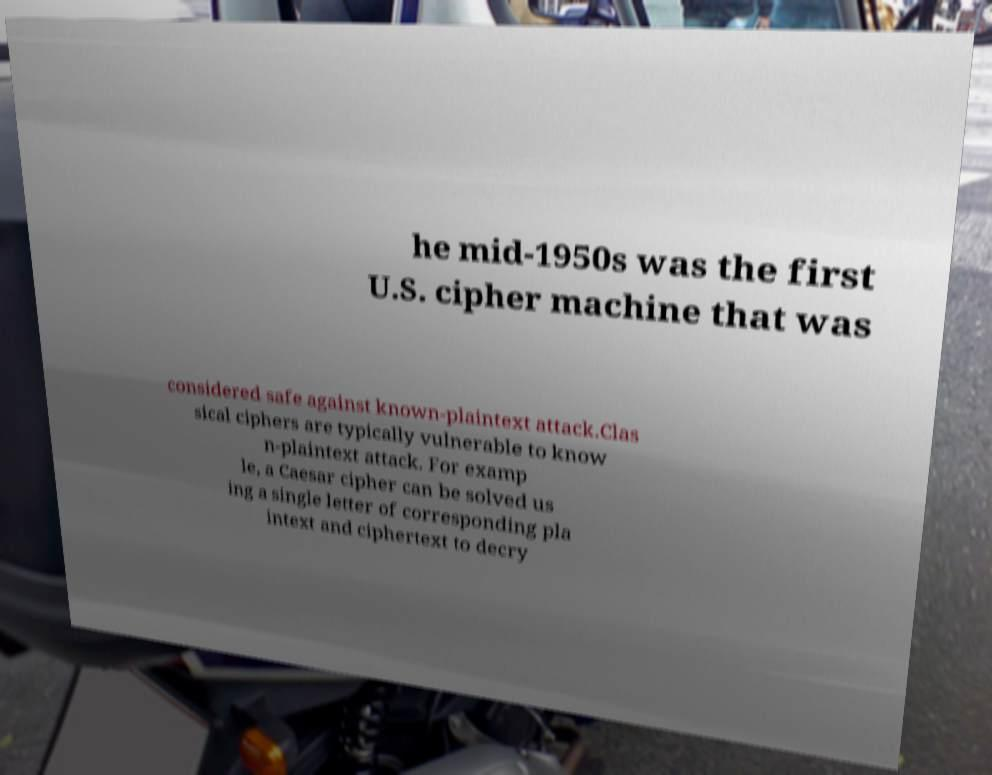I need the written content from this picture converted into text. Can you do that? he mid-1950s was the first U.S. cipher machine that was considered safe against known-plaintext attack.Clas sical ciphers are typically vulnerable to know n-plaintext attack. For examp le, a Caesar cipher can be solved us ing a single letter of corresponding pla intext and ciphertext to decry 